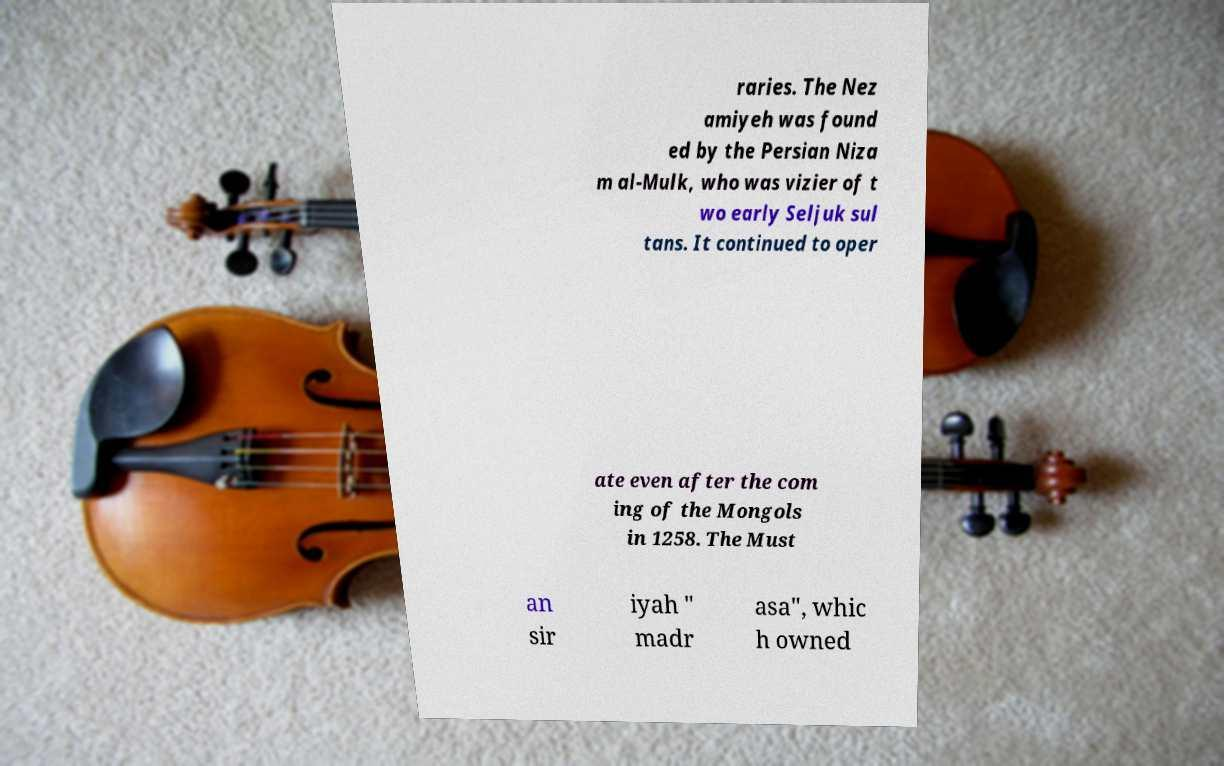Could you extract and type out the text from this image? raries. The Nez amiyeh was found ed by the Persian Niza m al-Mulk, who was vizier of t wo early Seljuk sul tans. It continued to oper ate even after the com ing of the Mongols in 1258. The Must an sir iyah " madr asa", whic h owned 